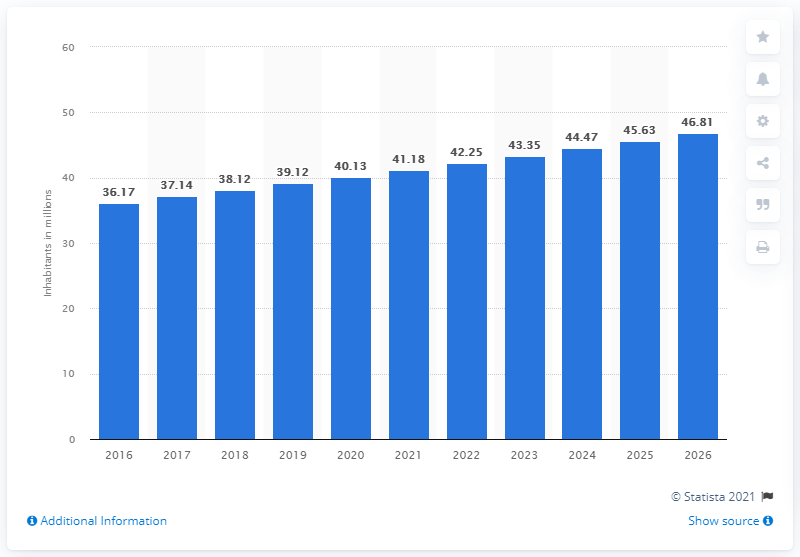What was the population of Iraq in 2020?
 40.13 